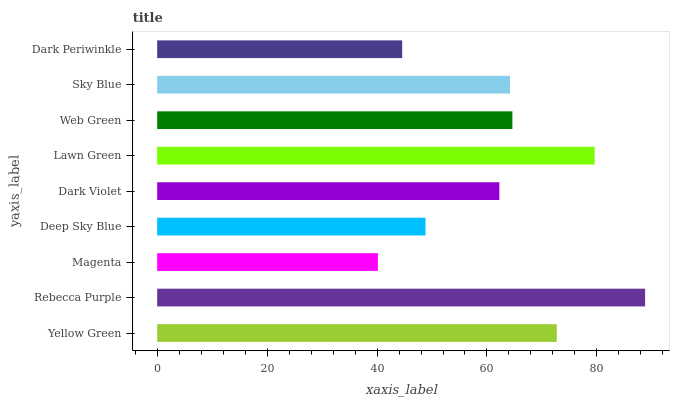Is Magenta the minimum?
Answer yes or no. Yes. Is Rebecca Purple the maximum?
Answer yes or no. Yes. Is Rebecca Purple the minimum?
Answer yes or no. No. Is Magenta the maximum?
Answer yes or no. No. Is Rebecca Purple greater than Magenta?
Answer yes or no. Yes. Is Magenta less than Rebecca Purple?
Answer yes or no. Yes. Is Magenta greater than Rebecca Purple?
Answer yes or no. No. Is Rebecca Purple less than Magenta?
Answer yes or no. No. Is Sky Blue the high median?
Answer yes or no. Yes. Is Sky Blue the low median?
Answer yes or no. Yes. Is Magenta the high median?
Answer yes or no. No. Is Yellow Green the low median?
Answer yes or no. No. 